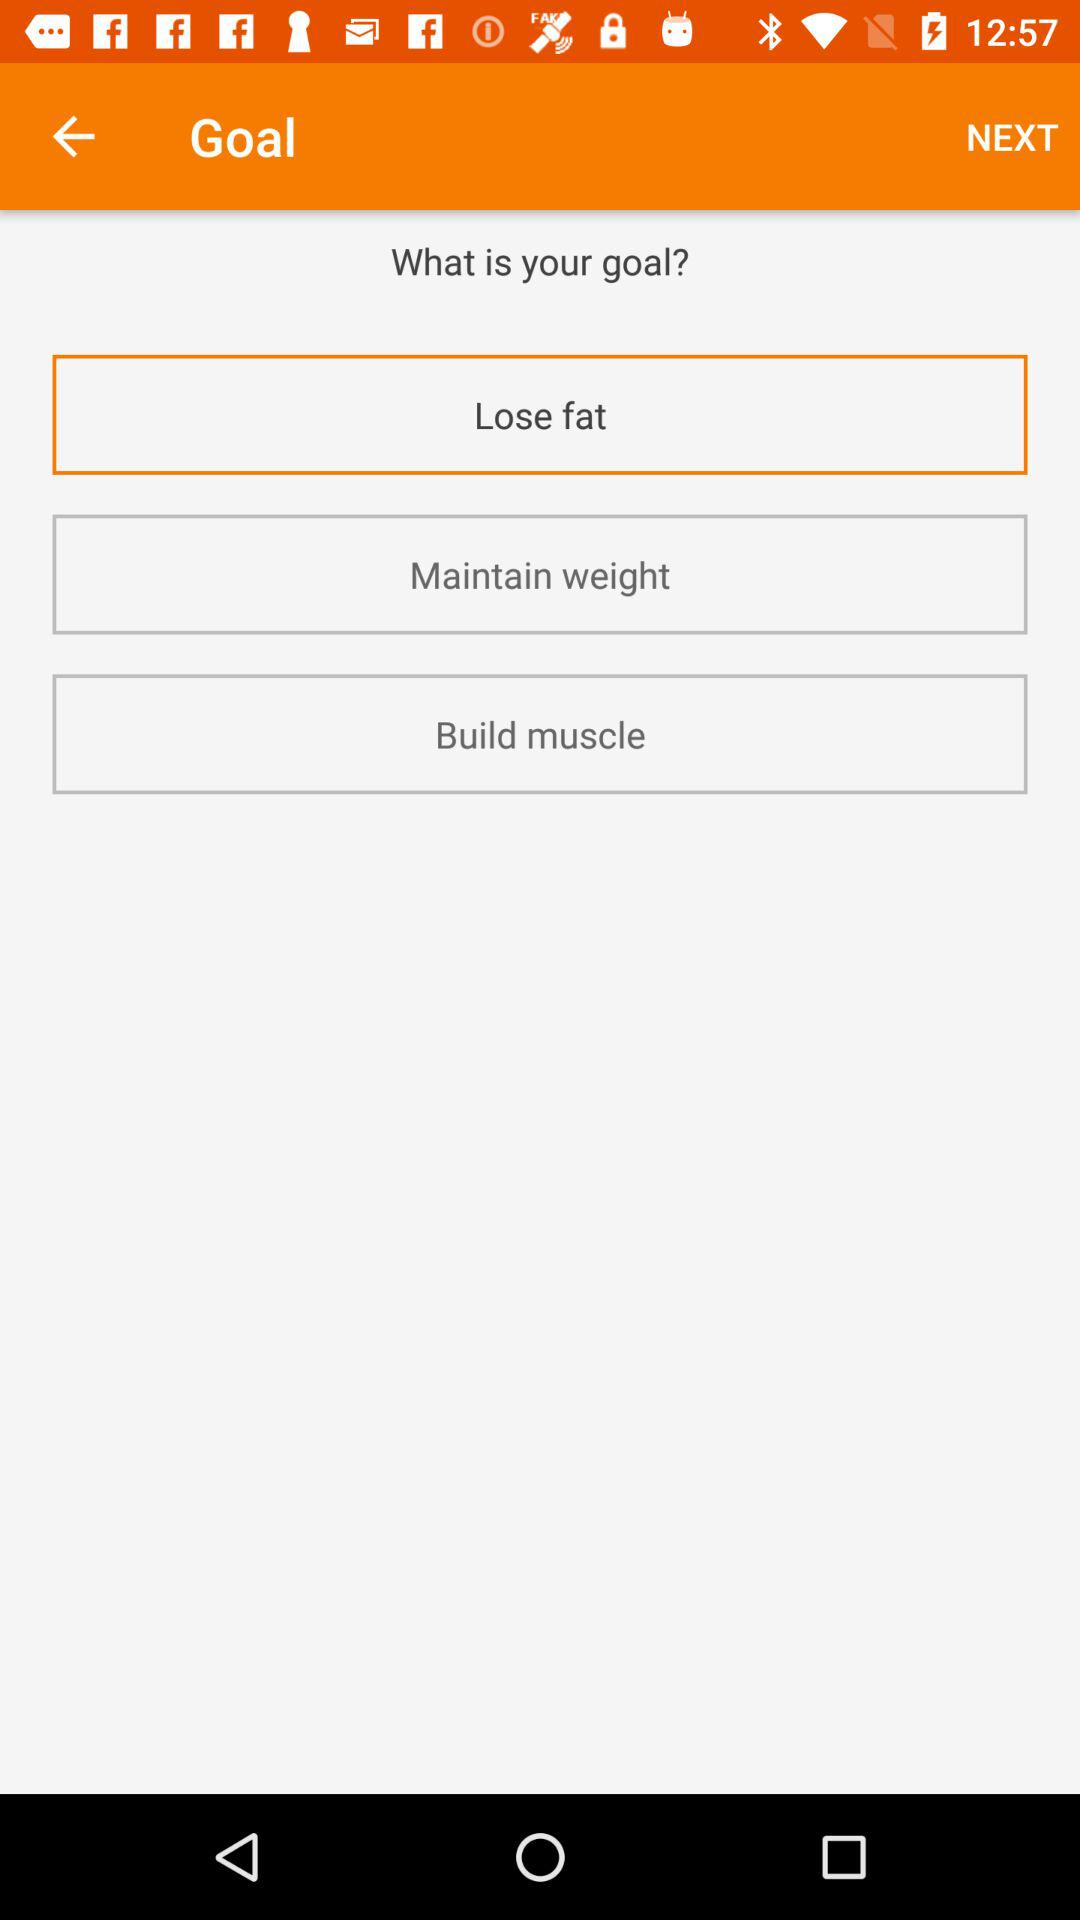Which goal has been selected? The selected goal is "Lose fat". 